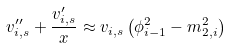Convert formula to latex. <formula><loc_0><loc_0><loc_500><loc_500>v _ { i , s } ^ { \prime \prime } + \frac { v _ { i , s } ^ { \prime } } { x } \approx v _ { i , s } \left ( \phi ^ { 2 } _ { i - 1 } - m ^ { 2 } _ { 2 , i } \right )</formula> 